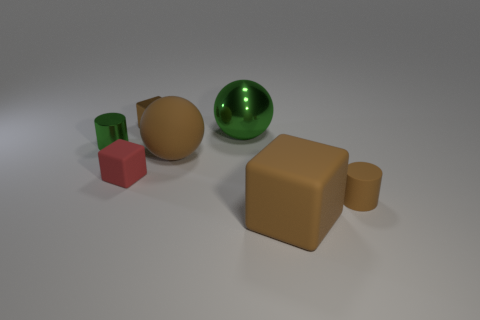Is the number of big things greater than the number of big green spheres?
Your answer should be compact. Yes. Does the big object in front of the tiny red thing have the same color as the tiny rubber cylinder?
Keep it short and to the point. Yes. What is the color of the small metal cylinder?
Make the answer very short. Green. There is a small object that is in front of the red block; are there any brown metal cubes that are on the right side of it?
Your answer should be very brief. No. What is the shape of the green thing that is to the right of the cylinder left of the large green shiny sphere?
Your response must be concise. Sphere. Are there fewer brown rubber cylinders than large matte objects?
Make the answer very short. Yes. Does the tiny red block have the same material as the tiny green cylinder?
Give a very brief answer. No. There is a rubber object that is both to the left of the tiny brown rubber thing and right of the large metallic ball; what is its color?
Offer a terse response. Brown. Are there any other metal cylinders of the same size as the brown cylinder?
Give a very brief answer. Yes. There is a brown cube behind the tiny green shiny cylinder to the left of the brown cylinder; what is its size?
Your response must be concise. Small. 